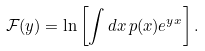<formula> <loc_0><loc_0><loc_500><loc_500>\mathcal { F } ( y ) = \ln \left [ \int d x \, p ( x ) e ^ { y x } \right ] .</formula> 